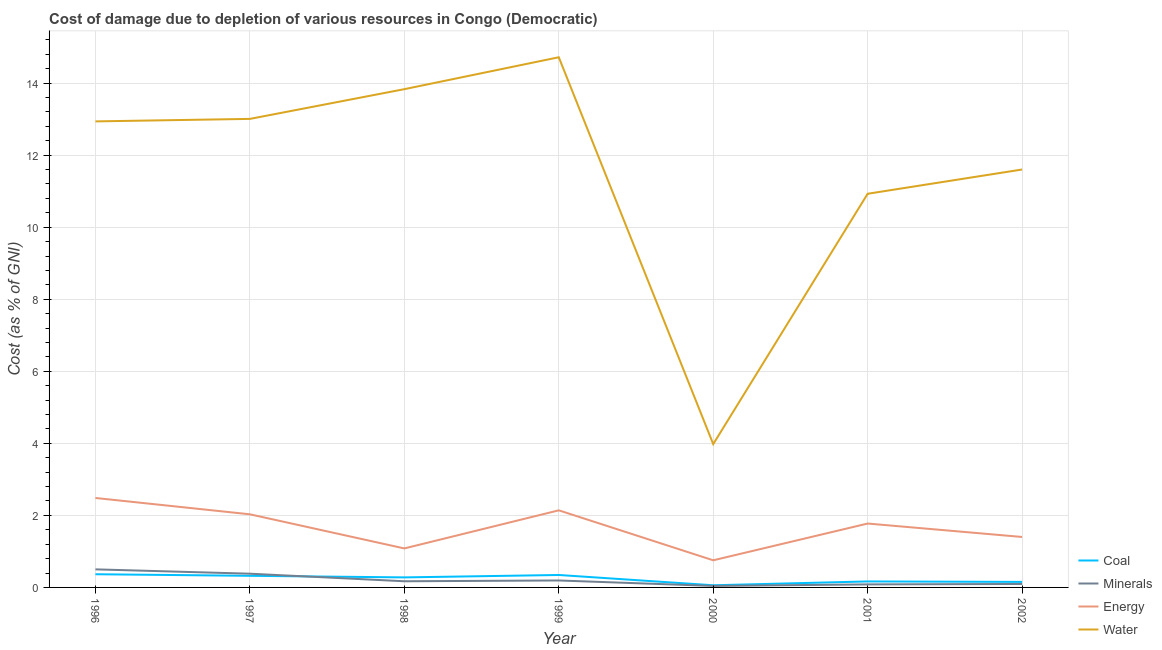What is the cost of damage due to depletion of coal in 1997?
Make the answer very short. 0.32. Across all years, what is the maximum cost of damage due to depletion of water?
Give a very brief answer. 14.72. Across all years, what is the minimum cost of damage due to depletion of water?
Provide a short and direct response. 3.98. What is the total cost of damage due to depletion of water in the graph?
Your answer should be compact. 81. What is the difference between the cost of damage due to depletion of energy in 1997 and that in 2002?
Provide a short and direct response. 0.63. What is the difference between the cost of damage due to depletion of coal in 2001 and the cost of damage due to depletion of water in 1998?
Offer a very short reply. -13.67. What is the average cost of damage due to depletion of coal per year?
Provide a succinct answer. 0.24. In the year 2002, what is the difference between the cost of damage due to depletion of energy and cost of damage due to depletion of water?
Give a very brief answer. -10.2. What is the ratio of the cost of damage due to depletion of coal in 1996 to that in 2002?
Provide a short and direct response. 2.39. Is the difference between the cost of damage due to depletion of minerals in 1998 and 2001 greater than the difference between the cost of damage due to depletion of energy in 1998 and 2001?
Your response must be concise. Yes. What is the difference between the highest and the second highest cost of damage due to depletion of minerals?
Keep it short and to the point. 0.12. What is the difference between the highest and the lowest cost of damage due to depletion of coal?
Ensure brevity in your answer.  0.31. Is it the case that in every year, the sum of the cost of damage due to depletion of coal and cost of damage due to depletion of minerals is greater than the cost of damage due to depletion of energy?
Keep it short and to the point. No. Does the cost of damage due to depletion of coal monotonically increase over the years?
Keep it short and to the point. No. Is the cost of damage due to depletion of coal strictly greater than the cost of damage due to depletion of minerals over the years?
Offer a very short reply. No. How many years are there in the graph?
Your answer should be compact. 7. What is the difference between two consecutive major ticks on the Y-axis?
Offer a very short reply. 2. Does the graph contain grids?
Keep it short and to the point. Yes. How are the legend labels stacked?
Your response must be concise. Vertical. What is the title of the graph?
Make the answer very short. Cost of damage due to depletion of various resources in Congo (Democratic) . Does "Secondary schools" appear as one of the legend labels in the graph?
Your answer should be very brief. No. What is the label or title of the X-axis?
Offer a very short reply. Year. What is the label or title of the Y-axis?
Keep it short and to the point. Cost (as % of GNI). What is the Cost (as % of GNI) in Coal in 1996?
Keep it short and to the point. 0.37. What is the Cost (as % of GNI) in Minerals in 1996?
Make the answer very short. 0.5. What is the Cost (as % of GNI) of Energy in 1996?
Offer a very short reply. 2.48. What is the Cost (as % of GNI) in Water in 1996?
Your answer should be very brief. 12.94. What is the Cost (as % of GNI) of Coal in 1997?
Make the answer very short. 0.32. What is the Cost (as % of GNI) of Minerals in 1997?
Offer a very short reply. 0.38. What is the Cost (as % of GNI) of Energy in 1997?
Your response must be concise. 2.03. What is the Cost (as % of GNI) of Water in 1997?
Your response must be concise. 13.01. What is the Cost (as % of GNI) in Coal in 1998?
Provide a succinct answer. 0.28. What is the Cost (as % of GNI) in Minerals in 1998?
Provide a succinct answer. 0.17. What is the Cost (as % of GNI) in Energy in 1998?
Provide a succinct answer. 1.08. What is the Cost (as % of GNI) in Water in 1998?
Provide a succinct answer. 13.83. What is the Cost (as % of GNI) of Coal in 1999?
Your response must be concise. 0.35. What is the Cost (as % of GNI) in Minerals in 1999?
Provide a succinct answer. 0.19. What is the Cost (as % of GNI) in Energy in 1999?
Ensure brevity in your answer.  2.14. What is the Cost (as % of GNI) of Water in 1999?
Your answer should be very brief. 14.72. What is the Cost (as % of GNI) in Coal in 2000?
Your response must be concise. 0.06. What is the Cost (as % of GNI) in Minerals in 2000?
Ensure brevity in your answer.  0.04. What is the Cost (as % of GNI) of Energy in 2000?
Your response must be concise. 0.75. What is the Cost (as % of GNI) of Water in 2000?
Your response must be concise. 3.98. What is the Cost (as % of GNI) in Coal in 2001?
Ensure brevity in your answer.  0.17. What is the Cost (as % of GNI) in Minerals in 2001?
Offer a terse response. 0.08. What is the Cost (as % of GNI) in Energy in 2001?
Make the answer very short. 1.77. What is the Cost (as % of GNI) in Water in 2001?
Ensure brevity in your answer.  10.93. What is the Cost (as % of GNI) of Coal in 2002?
Give a very brief answer. 0.15. What is the Cost (as % of GNI) of Minerals in 2002?
Your answer should be very brief. 0.1. What is the Cost (as % of GNI) in Energy in 2002?
Keep it short and to the point. 1.4. What is the Cost (as % of GNI) of Water in 2002?
Make the answer very short. 11.6. Across all years, what is the maximum Cost (as % of GNI) of Coal?
Your answer should be compact. 0.37. Across all years, what is the maximum Cost (as % of GNI) of Minerals?
Your answer should be very brief. 0.5. Across all years, what is the maximum Cost (as % of GNI) of Energy?
Offer a very short reply. 2.48. Across all years, what is the maximum Cost (as % of GNI) in Water?
Keep it short and to the point. 14.72. Across all years, what is the minimum Cost (as % of GNI) in Coal?
Your answer should be very brief. 0.06. Across all years, what is the minimum Cost (as % of GNI) in Minerals?
Give a very brief answer. 0.04. Across all years, what is the minimum Cost (as % of GNI) in Energy?
Make the answer very short. 0.75. Across all years, what is the minimum Cost (as % of GNI) of Water?
Provide a succinct answer. 3.98. What is the total Cost (as % of GNI) in Coal in the graph?
Give a very brief answer. 1.69. What is the total Cost (as % of GNI) of Minerals in the graph?
Your answer should be compact. 1.47. What is the total Cost (as % of GNI) of Energy in the graph?
Provide a succinct answer. 11.66. What is the total Cost (as % of GNI) in Water in the graph?
Your answer should be compact. 81. What is the difference between the Cost (as % of GNI) of Coal in 1996 and that in 1997?
Your response must be concise. 0.04. What is the difference between the Cost (as % of GNI) in Minerals in 1996 and that in 1997?
Make the answer very short. 0.12. What is the difference between the Cost (as % of GNI) of Energy in 1996 and that in 1997?
Make the answer very short. 0.45. What is the difference between the Cost (as % of GNI) in Water in 1996 and that in 1997?
Make the answer very short. -0.07. What is the difference between the Cost (as % of GNI) of Coal in 1996 and that in 1998?
Provide a short and direct response. 0.09. What is the difference between the Cost (as % of GNI) in Minerals in 1996 and that in 1998?
Offer a terse response. 0.33. What is the difference between the Cost (as % of GNI) in Energy in 1996 and that in 1998?
Ensure brevity in your answer.  1.4. What is the difference between the Cost (as % of GNI) in Water in 1996 and that in 1998?
Offer a terse response. -0.89. What is the difference between the Cost (as % of GNI) in Coal in 1996 and that in 1999?
Keep it short and to the point. 0.02. What is the difference between the Cost (as % of GNI) of Minerals in 1996 and that in 1999?
Your response must be concise. 0.31. What is the difference between the Cost (as % of GNI) of Energy in 1996 and that in 1999?
Ensure brevity in your answer.  0.34. What is the difference between the Cost (as % of GNI) of Water in 1996 and that in 1999?
Give a very brief answer. -1.78. What is the difference between the Cost (as % of GNI) of Coal in 1996 and that in 2000?
Offer a very short reply. 0.31. What is the difference between the Cost (as % of GNI) in Minerals in 1996 and that in 2000?
Offer a very short reply. 0.46. What is the difference between the Cost (as % of GNI) in Energy in 1996 and that in 2000?
Provide a short and direct response. 1.73. What is the difference between the Cost (as % of GNI) of Water in 1996 and that in 2000?
Your response must be concise. 8.96. What is the difference between the Cost (as % of GNI) in Coal in 1996 and that in 2001?
Your answer should be compact. 0.2. What is the difference between the Cost (as % of GNI) in Minerals in 1996 and that in 2001?
Ensure brevity in your answer.  0.42. What is the difference between the Cost (as % of GNI) of Energy in 1996 and that in 2001?
Ensure brevity in your answer.  0.71. What is the difference between the Cost (as % of GNI) of Water in 1996 and that in 2001?
Give a very brief answer. 2.01. What is the difference between the Cost (as % of GNI) of Coal in 1996 and that in 2002?
Offer a very short reply. 0.21. What is the difference between the Cost (as % of GNI) in Minerals in 1996 and that in 2002?
Ensure brevity in your answer.  0.41. What is the difference between the Cost (as % of GNI) in Energy in 1996 and that in 2002?
Your answer should be compact. 1.08. What is the difference between the Cost (as % of GNI) of Water in 1996 and that in 2002?
Your response must be concise. 1.34. What is the difference between the Cost (as % of GNI) of Coal in 1997 and that in 1998?
Your response must be concise. 0.04. What is the difference between the Cost (as % of GNI) in Minerals in 1997 and that in 1998?
Give a very brief answer. 0.21. What is the difference between the Cost (as % of GNI) in Energy in 1997 and that in 1998?
Make the answer very short. 0.95. What is the difference between the Cost (as % of GNI) in Water in 1997 and that in 1998?
Offer a terse response. -0.83. What is the difference between the Cost (as % of GNI) in Coal in 1997 and that in 1999?
Offer a terse response. -0.02. What is the difference between the Cost (as % of GNI) in Minerals in 1997 and that in 1999?
Provide a short and direct response. 0.19. What is the difference between the Cost (as % of GNI) in Energy in 1997 and that in 1999?
Your response must be concise. -0.11. What is the difference between the Cost (as % of GNI) of Water in 1997 and that in 1999?
Your response must be concise. -1.71. What is the difference between the Cost (as % of GNI) of Coal in 1997 and that in 2000?
Offer a terse response. 0.26. What is the difference between the Cost (as % of GNI) in Minerals in 1997 and that in 2000?
Provide a short and direct response. 0.34. What is the difference between the Cost (as % of GNI) in Energy in 1997 and that in 2000?
Keep it short and to the point. 1.28. What is the difference between the Cost (as % of GNI) in Water in 1997 and that in 2000?
Provide a short and direct response. 9.03. What is the difference between the Cost (as % of GNI) in Coal in 1997 and that in 2001?
Your answer should be very brief. 0.16. What is the difference between the Cost (as % of GNI) in Minerals in 1997 and that in 2001?
Offer a terse response. 0.3. What is the difference between the Cost (as % of GNI) of Energy in 1997 and that in 2001?
Give a very brief answer. 0.26. What is the difference between the Cost (as % of GNI) in Water in 1997 and that in 2001?
Ensure brevity in your answer.  2.08. What is the difference between the Cost (as % of GNI) in Coal in 1997 and that in 2002?
Ensure brevity in your answer.  0.17. What is the difference between the Cost (as % of GNI) of Minerals in 1997 and that in 2002?
Ensure brevity in your answer.  0.28. What is the difference between the Cost (as % of GNI) in Energy in 1997 and that in 2002?
Your response must be concise. 0.63. What is the difference between the Cost (as % of GNI) of Water in 1997 and that in 2002?
Your response must be concise. 1.41. What is the difference between the Cost (as % of GNI) in Coal in 1998 and that in 1999?
Offer a terse response. -0.07. What is the difference between the Cost (as % of GNI) of Minerals in 1998 and that in 1999?
Your answer should be very brief. -0.02. What is the difference between the Cost (as % of GNI) in Energy in 1998 and that in 1999?
Provide a short and direct response. -1.06. What is the difference between the Cost (as % of GNI) in Water in 1998 and that in 1999?
Offer a very short reply. -0.89. What is the difference between the Cost (as % of GNI) of Coal in 1998 and that in 2000?
Provide a succinct answer. 0.22. What is the difference between the Cost (as % of GNI) of Minerals in 1998 and that in 2000?
Provide a succinct answer. 0.13. What is the difference between the Cost (as % of GNI) in Energy in 1998 and that in 2000?
Give a very brief answer. 0.33. What is the difference between the Cost (as % of GNI) of Water in 1998 and that in 2000?
Provide a short and direct response. 9.85. What is the difference between the Cost (as % of GNI) of Coal in 1998 and that in 2001?
Give a very brief answer. 0.11. What is the difference between the Cost (as % of GNI) of Minerals in 1998 and that in 2001?
Provide a short and direct response. 0.09. What is the difference between the Cost (as % of GNI) of Energy in 1998 and that in 2001?
Your answer should be very brief. -0.69. What is the difference between the Cost (as % of GNI) in Water in 1998 and that in 2001?
Offer a terse response. 2.9. What is the difference between the Cost (as % of GNI) of Coal in 1998 and that in 2002?
Your response must be concise. 0.13. What is the difference between the Cost (as % of GNI) of Minerals in 1998 and that in 2002?
Offer a terse response. 0.07. What is the difference between the Cost (as % of GNI) in Energy in 1998 and that in 2002?
Your answer should be very brief. -0.32. What is the difference between the Cost (as % of GNI) in Water in 1998 and that in 2002?
Your answer should be very brief. 2.23. What is the difference between the Cost (as % of GNI) in Coal in 1999 and that in 2000?
Provide a short and direct response. 0.29. What is the difference between the Cost (as % of GNI) in Minerals in 1999 and that in 2000?
Ensure brevity in your answer.  0.15. What is the difference between the Cost (as % of GNI) in Energy in 1999 and that in 2000?
Your response must be concise. 1.39. What is the difference between the Cost (as % of GNI) of Water in 1999 and that in 2000?
Offer a very short reply. 10.74. What is the difference between the Cost (as % of GNI) of Coal in 1999 and that in 2001?
Keep it short and to the point. 0.18. What is the difference between the Cost (as % of GNI) in Minerals in 1999 and that in 2001?
Offer a terse response. 0.11. What is the difference between the Cost (as % of GNI) of Energy in 1999 and that in 2001?
Make the answer very short. 0.37. What is the difference between the Cost (as % of GNI) in Water in 1999 and that in 2001?
Ensure brevity in your answer.  3.79. What is the difference between the Cost (as % of GNI) of Coal in 1999 and that in 2002?
Offer a very short reply. 0.19. What is the difference between the Cost (as % of GNI) in Minerals in 1999 and that in 2002?
Keep it short and to the point. 0.1. What is the difference between the Cost (as % of GNI) in Energy in 1999 and that in 2002?
Offer a very short reply. 0.74. What is the difference between the Cost (as % of GNI) of Water in 1999 and that in 2002?
Your response must be concise. 3.12. What is the difference between the Cost (as % of GNI) of Coal in 2000 and that in 2001?
Your response must be concise. -0.11. What is the difference between the Cost (as % of GNI) in Minerals in 2000 and that in 2001?
Offer a very short reply. -0.04. What is the difference between the Cost (as % of GNI) in Energy in 2000 and that in 2001?
Offer a terse response. -1.02. What is the difference between the Cost (as % of GNI) of Water in 2000 and that in 2001?
Your answer should be compact. -6.95. What is the difference between the Cost (as % of GNI) of Coal in 2000 and that in 2002?
Keep it short and to the point. -0.09. What is the difference between the Cost (as % of GNI) in Minerals in 2000 and that in 2002?
Give a very brief answer. -0.05. What is the difference between the Cost (as % of GNI) of Energy in 2000 and that in 2002?
Provide a short and direct response. -0.65. What is the difference between the Cost (as % of GNI) of Water in 2000 and that in 2002?
Make the answer very short. -7.62. What is the difference between the Cost (as % of GNI) in Coal in 2001 and that in 2002?
Your response must be concise. 0.01. What is the difference between the Cost (as % of GNI) in Minerals in 2001 and that in 2002?
Ensure brevity in your answer.  -0.01. What is the difference between the Cost (as % of GNI) in Energy in 2001 and that in 2002?
Your answer should be compact. 0.37. What is the difference between the Cost (as % of GNI) of Water in 2001 and that in 2002?
Make the answer very short. -0.67. What is the difference between the Cost (as % of GNI) in Coal in 1996 and the Cost (as % of GNI) in Minerals in 1997?
Your response must be concise. -0.01. What is the difference between the Cost (as % of GNI) of Coal in 1996 and the Cost (as % of GNI) of Energy in 1997?
Provide a succinct answer. -1.66. What is the difference between the Cost (as % of GNI) of Coal in 1996 and the Cost (as % of GNI) of Water in 1997?
Ensure brevity in your answer.  -12.64. What is the difference between the Cost (as % of GNI) in Minerals in 1996 and the Cost (as % of GNI) in Energy in 1997?
Keep it short and to the point. -1.53. What is the difference between the Cost (as % of GNI) of Minerals in 1996 and the Cost (as % of GNI) of Water in 1997?
Make the answer very short. -12.51. What is the difference between the Cost (as % of GNI) of Energy in 1996 and the Cost (as % of GNI) of Water in 1997?
Ensure brevity in your answer.  -10.52. What is the difference between the Cost (as % of GNI) in Coal in 1996 and the Cost (as % of GNI) in Minerals in 1998?
Your answer should be compact. 0.2. What is the difference between the Cost (as % of GNI) in Coal in 1996 and the Cost (as % of GNI) in Energy in 1998?
Your answer should be very brief. -0.72. What is the difference between the Cost (as % of GNI) in Coal in 1996 and the Cost (as % of GNI) in Water in 1998?
Give a very brief answer. -13.47. What is the difference between the Cost (as % of GNI) in Minerals in 1996 and the Cost (as % of GNI) in Energy in 1998?
Your response must be concise. -0.58. What is the difference between the Cost (as % of GNI) in Minerals in 1996 and the Cost (as % of GNI) in Water in 1998?
Ensure brevity in your answer.  -13.33. What is the difference between the Cost (as % of GNI) of Energy in 1996 and the Cost (as % of GNI) of Water in 1998?
Your answer should be compact. -11.35. What is the difference between the Cost (as % of GNI) of Coal in 1996 and the Cost (as % of GNI) of Minerals in 1999?
Provide a succinct answer. 0.17. What is the difference between the Cost (as % of GNI) of Coal in 1996 and the Cost (as % of GNI) of Energy in 1999?
Provide a short and direct response. -1.77. What is the difference between the Cost (as % of GNI) of Coal in 1996 and the Cost (as % of GNI) of Water in 1999?
Your response must be concise. -14.35. What is the difference between the Cost (as % of GNI) in Minerals in 1996 and the Cost (as % of GNI) in Energy in 1999?
Your response must be concise. -1.64. What is the difference between the Cost (as % of GNI) in Minerals in 1996 and the Cost (as % of GNI) in Water in 1999?
Make the answer very short. -14.22. What is the difference between the Cost (as % of GNI) of Energy in 1996 and the Cost (as % of GNI) of Water in 1999?
Keep it short and to the point. -12.23. What is the difference between the Cost (as % of GNI) in Coal in 1996 and the Cost (as % of GNI) in Minerals in 2000?
Your response must be concise. 0.32. What is the difference between the Cost (as % of GNI) in Coal in 1996 and the Cost (as % of GNI) in Energy in 2000?
Provide a short and direct response. -0.39. What is the difference between the Cost (as % of GNI) in Coal in 1996 and the Cost (as % of GNI) in Water in 2000?
Ensure brevity in your answer.  -3.61. What is the difference between the Cost (as % of GNI) of Minerals in 1996 and the Cost (as % of GNI) of Energy in 2000?
Ensure brevity in your answer.  -0.25. What is the difference between the Cost (as % of GNI) of Minerals in 1996 and the Cost (as % of GNI) of Water in 2000?
Make the answer very short. -3.48. What is the difference between the Cost (as % of GNI) in Energy in 1996 and the Cost (as % of GNI) in Water in 2000?
Keep it short and to the point. -1.5. What is the difference between the Cost (as % of GNI) in Coal in 1996 and the Cost (as % of GNI) in Minerals in 2001?
Provide a short and direct response. 0.28. What is the difference between the Cost (as % of GNI) in Coal in 1996 and the Cost (as % of GNI) in Energy in 2001?
Your answer should be very brief. -1.41. What is the difference between the Cost (as % of GNI) in Coal in 1996 and the Cost (as % of GNI) in Water in 2001?
Ensure brevity in your answer.  -10.56. What is the difference between the Cost (as % of GNI) of Minerals in 1996 and the Cost (as % of GNI) of Energy in 2001?
Your response must be concise. -1.27. What is the difference between the Cost (as % of GNI) in Minerals in 1996 and the Cost (as % of GNI) in Water in 2001?
Provide a short and direct response. -10.43. What is the difference between the Cost (as % of GNI) of Energy in 1996 and the Cost (as % of GNI) of Water in 2001?
Provide a succinct answer. -8.45. What is the difference between the Cost (as % of GNI) of Coal in 1996 and the Cost (as % of GNI) of Minerals in 2002?
Your answer should be compact. 0.27. What is the difference between the Cost (as % of GNI) in Coal in 1996 and the Cost (as % of GNI) in Energy in 2002?
Offer a terse response. -1.03. What is the difference between the Cost (as % of GNI) in Coal in 1996 and the Cost (as % of GNI) in Water in 2002?
Your answer should be very brief. -11.24. What is the difference between the Cost (as % of GNI) of Minerals in 1996 and the Cost (as % of GNI) of Energy in 2002?
Make the answer very short. -0.9. What is the difference between the Cost (as % of GNI) in Minerals in 1996 and the Cost (as % of GNI) in Water in 2002?
Ensure brevity in your answer.  -11.1. What is the difference between the Cost (as % of GNI) of Energy in 1996 and the Cost (as % of GNI) of Water in 2002?
Offer a very short reply. -9.12. What is the difference between the Cost (as % of GNI) in Coal in 1997 and the Cost (as % of GNI) in Minerals in 1998?
Ensure brevity in your answer.  0.15. What is the difference between the Cost (as % of GNI) in Coal in 1997 and the Cost (as % of GNI) in Energy in 1998?
Your response must be concise. -0.76. What is the difference between the Cost (as % of GNI) in Coal in 1997 and the Cost (as % of GNI) in Water in 1998?
Your answer should be very brief. -13.51. What is the difference between the Cost (as % of GNI) of Minerals in 1997 and the Cost (as % of GNI) of Energy in 1998?
Provide a short and direct response. -0.7. What is the difference between the Cost (as % of GNI) in Minerals in 1997 and the Cost (as % of GNI) in Water in 1998?
Give a very brief answer. -13.45. What is the difference between the Cost (as % of GNI) of Energy in 1997 and the Cost (as % of GNI) of Water in 1998?
Offer a terse response. -11.8. What is the difference between the Cost (as % of GNI) in Coal in 1997 and the Cost (as % of GNI) in Minerals in 1999?
Ensure brevity in your answer.  0.13. What is the difference between the Cost (as % of GNI) in Coal in 1997 and the Cost (as % of GNI) in Energy in 1999?
Your answer should be very brief. -1.82. What is the difference between the Cost (as % of GNI) in Coal in 1997 and the Cost (as % of GNI) in Water in 1999?
Your response must be concise. -14.4. What is the difference between the Cost (as % of GNI) of Minerals in 1997 and the Cost (as % of GNI) of Energy in 1999?
Give a very brief answer. -1.76. What is the difference between the Cost (as % of GNI) in Minerals in 1997 and the Cost (as % of GNI) in Water in 1999?
Your answer should be compact. -14.34. What is the difference between the Cost (as % of GNI) in Energy in 1997 and the Cost (as % of GNI) in Water in 1999?
Give a very brief answer. -12.69. What is the difference between the Cost (as % of GNI) of Coal in 1997 and the Cost (as % of GNI) of Minerals in 2000?
Offer a very short reply. 0.28. What is the difference between the Cost (as % of GNI) in Coal in 1997 and the Cost (as % of GNI) in Energy in 2000?
Your response must be concise. -0.43. What is the difference between the Cost (as % of GNI) of Coal in 1997 and the Cost (as % of GNI) of Water in 2000?
Keep it short and to the point. -3.66. What is the difference between the Cost (as % of GNI) of Minerals in 1997 and the Cost (as % of GNI) of Energy in 2000?
Make the answer very short. -0.37. What is the difference between the Cost (as % of GNI) in Minerals in 1997 and the Cost (as % of GNI) in Water in 2000?
Offer a terse response. -3.6. What is the difference between the Cost (as % of GNI) of Energy in 1997 and the Cost (as % of GNI) of Water in 2000?
Offer a terse response. -1.95. What is the difference between the Cost (as % of GNI) in Coal in 1997 and the Cost (as % of GNI) in Minerals in 2001?
Your response must be concise. 0.24. What is the difference between the Cost (as % of GNI) of Coal in 1997 and the Cost (as % of GNI) of Energy in 2001?
Keep it short and to the point. -1.45. What is the difference between the Cost (as % of GNI) of Coal in 1997 and the Cost (as % of GNI) of Water in 2001?
Keep it short and to the point. -10.61. What is the difference between the Cost (as % of GNI) in Minerals in 1997 and the Cost (as % of GNI) in Energy in 2001?
Make the answer very short. -1.39. What is the difference between the Cost (as % of GNI) in Minerals in 1997 and the Cost (as % of GNI) in Water in 2001?
Your answer should be compact. -10.55. What is the difference between the Cost (as % of GNI) in Energy in 1997 and the Cost (as % of GNI) in Water in 2001?
Your answer should be very brief. -8.9. What is the difference between the Cost (as % of GNI) of Coal in 1997 and the Cost (as % of GNI) of Minerals in 2002?
Offer a very short reply. 0.23. What is the difference between the Cost (as % of GNI) of Coal in 1997 and the Cost (as % of GNI) of Energy in 2002?
Your answer should be compact. -1.08. What is the difference between the Cost (as % of GNI) in Coal in 1997 and the Cost (as % of GNI) in Water in 2002?
Make the answer very short. -11.28. What is the difference between the Cost (as % of GNI) in Minerals in 1997 and the Cost (as % of GNI) in Energy in 2002?
Offer a terse response. -1.02. What is the difference between the Cost (as % of GNI) in Minerals in 1997 and the Cost (as % of GNI) in Water in 2002?
Make the answer very short. -11.22. What is the difference between the Cost (as % of GNI) of Energy in 1997 and the Cost (as % of GNI) of Water in 2002?
Provide a short and direct response. -9.57. What is the difference between the Cost (as % of GNI) in Coal in 1998 and the Cost (as % of GNI) in Minerals in 1999?
Give a very brief answer. 0.09. What is the difference between the Cost (as % of GNI) of Coal in 1998 and the Cost (as % of GNI) of Energy in 1999?
Offer a very short reply. -1.86. What is the difference between the Cost (as % of GNI) of Coal in 1998 and the Cost (as % of GNI) of Water in 1999?
Ensure brevity in your answer.  -14.44. What is the difference between the Cost (as % of GNI) in Minerals in 1998 and the Cost (as % of GNI) in Energy in 1999?
Make the answer very short. -1.97. What is the difference between the Cost (as % of GNI) of Minerals in 1998 and the Cost (as % of GNI) of Water in 1999?
Your response must be concise. -14.55. What is the difference between the Cost (as % of GNI) in Energy in 1998 and the Cost (as % of GNI) in Water in 1999?
Offer a very short reply. -13.64. What is the difference between the Cost (as % of GNI) of Coal in 1998 and the Cost (as % of GNI) of Minerals in 2000?
Provide a succinct answer. 0.24. What is the difference between the Cost (as % of GNI) of Coal in 1998 and the Cost (as % of GNI) of Energy in 2000?
Provide a succinct answer. -0.47. What is the difference between the Cost (as % of GNI) of Coal in 1998 and the Cost (as % of GNI) of Water in 2000?
Your response must be concise. -3.7. What is the difference between the Cost (as % of GNI) of Minerals in 1998 and the Cost (as % of GNI) of Energy in 2000?
Make the answer very short. -0.58. What is the difference between the Cost (as % of GNI) of Minerals in 1998 and the Cost (as % of GNI) of Water in 2000?
Give a very brief answer. -3.81. What is the difference between the Cost (as % of GNI) in Energy in 1998 and the Cost (as % of GNI) in Water in 2000?
Ensure brevity in your answer.  -2.9. What is the difference between the Cost (as % of GNI) in Coal in 1998 and the Cost (as % of GNI) in Minerals in 2001?
Ensure brevity in your answer.  0.2. What is the difference between the Cost (as % of GNI) of Coal in 1998 and the Cost (as % of GNI) of Energy in 2001?
Offer a terse response. -1.49. What is the difference between the Cost (as % of GNI) in Coal in 1998 and the Cost (as % of GNI) in Water in 2001?
Make the answer very short. -10.65. What is the difference between the Cost (as % of GNI) in Minerals in 1998 and the Cost (as % of GNI) in Energy in 2001?
Give a very brief answer. -1.6. What is the difference between the Cost (as % of GNI) in Minerals in 1998 and the Cost (as % of GNI) in Water in 2001?
Make the answer very short. -10.76. What is the difference between the Cost (as % of GNI) in Energy in 1998 and the Cost (as % of GNI) in Water in 2001?
Your response must be concise. -9.85. What is the difference between the Cost (as % of GNI) in Coal in 1998 and the Cost (as % of GNI) in Minerals in 2002?
Your response must be concise. 0.18. What is the difference between the Cost (as % of GNI) in Coal in 1998 and the Cost (as % of GNI) in Energy in 2002?
Make the answer very short. -1.12. What is the difference between the Cost (as % of GNI) in Coal in 1998 and the Cost (as % of GNI) in Water in 2002?
Offer a terse response. -11.32. What is the difference between the Cost (as % of GNI) in Minerals in 1998 and the Cost (as % of GNI) in Energy in 2002?
Ensure brevity in your answer.  -1.23. What is the difference between the Cost (as % of GNI) in Minerals in 1998 and the Cost (as % of GNI) in Water in 2002?
Provide a short and direct response. -11.43. What is the difference between the Cost (as % of GNI) of Energy in 1998 and the Cost (as % of GNI) of Water in 2002?
Ensure brevity in your answer.  -10.52. What is the difference between the Cost (as % of GNI) of Coal in 1999 and the Cost (as % of GNI) of Minerals in 2000?
Give a very brief answer. 0.3. What is the difference between the Cost (as % of GNI) in Coal in 1999 and the Cost (as % of GNI) in Energy in 2000?
Ensure brevity in your answer.  -0.41. What is the difference between the Cost (as % of GNI) of Coal in 1999 and the Cost (as % of GNI) of Water in 2000?
Ensure brevity in your answer.  -3.63. What is the difference between the Cost (as % of GNI) of Minerals in 1999 and the Cost (as % of GNI) of Energy in 2000?
Provide a short and direct response. -0.56. What is the difference between the Cost (as % of GNI) of Minerals in 1999 and the Cost (as % of GNI) of Water in 2000?
Give a very brief answer. -3.79. What is the difference between the Cost (as % of GNI) of Energy in 1999 and the Cost (as % of GNI) of Water in 2000?
Offer a very short reply. -1.84. What is the difference between the Cost (as % of GNI) of Coal in 1999 and the Cost (as % of GNI) of Minerals in 2001?
Offer a very short reply. 0.26. What is the difference between the Cost (as % of GNI) of Coal in 1999 and the Cost (as % of GNI) of Energy in 2001?
Give a very brief answer. -1.43. What is the difference between the Cost (as % of GNI) in Coal in 1999 and the Cost (as % of GNI) in Water in 2001?
Offer a very short reply. -10.58. What is the difference between the Cost (as % of GNI) of Minerals in 1999 and the Cost (as % of GNI) of Energy in 2001?
Keep it short and to the point. -1.58. What is the difference between the Cost (as % of GNI) in Minerals in 1999 and the Cost (as % of GNI) in Water in 2001?
Provide a succinct answer. -10.74. What is the difference between the Cost (as % of GNI) of Energy in 1999 and the Cost (as % of GNI) of Water in 2001?
Offer a very short reply. -8.79. What is the difference between the Cost (as % of GNI) of Coal in 1999 and the Cost (as % of GNI) of Minerals in 2002?
Make the answer very short. 0.25. What is the difference between the Cost (as % of GNI) of Coal in 1999 and the Cost (as % of GNI) of Energy in 2002?
Give a very brief answer. -1.06. What is the difference between the Cost (as % of GNI) of Coal in 1999 and the Cost (as % of GNI) of Water in 2002?
Provide a succinct answer. -11.26. What is the difference between the Cost (as % of GNI) in Minerals in 1999 and the Cost (as % of GNI) in Energy in 2002?
Ensure brevity in your answer.  -1.21. What is the difference between the Cost (as % of GNI) of Minerals in 1999 and the Cost (as % of GNI) of Water in 2002?
Offer a very short reply. -11.41. What is the difference between the Cost (as % of GNI) of Energy in 1999 and the Cost (as % of GNI) of Water in 2002?
Keep it short and to the point. -9.46. What is the difference between the Cost (as % of GNI) of Coal in 2000 and the Cost (as % of GNI) of Minerals in 2001?
Give a very brief answer. -0.02. What is the difference between the Cost (as % of GNI) of Coal in 2000 and the Cost (as % of GNI) of Energy in 2001?
Make the answer very short. -1.71. What is the difference between the Cost (as % of GNI) of Coal in 2000 and the Cost (as % of GNI) of Water in 2001?
Make the answer very short. -10.87. What is the difference between the Cost (as % of GNI) of Minerals in 2000 and the Cost (as % of GNI) of Energy in 2001?
Provide a short and direct response. -1.73. What is the difference between the Cost (as % of GNI) of Minerals in 2000 and the Cost (as % of GNI) of Water in 2001?
Give a very brief answer. -10.89. What is the difference between the Cost (as % of GNI) of Energy in 2000 and the Cost (as % of GNI) of Water in 2001?
Give a very brief answer. -10.18. What is the difference between the Cost (as % of GNI) in Coal in 2000 and the Cost (as % of GNI) in Minerals in 2002?
Offer a very short reply. -0.04. What is the difference between the Cost (as % of GNI) of Coal in 2000 and the Cost (as % of GNI) of Energy in 2002?
Give a very brief answer. -1.34. What is the difference between the Cost (as % of GNI) of Coal in 2000 and the Cost (as % of GNI) of Water in 2002?
Provide a short and direct response. -11.54. What is the difference between the Cost (as % of GNI) in Minerals in 2000 and the Cost (as % of GNI) in Energy in 2002?
Your answer should be compact. -1.36. What is the difference between the Cost (as % of GNI) of Minerals in 2000 and the Cost (as % of GNI) of Water in 2002?
Your response must be concise. -11.56. What is the difference between the Cost (as % of GNI) of Energy in 2000 and the Cost (as % of GNI) of Water in 2002?
Provide a succinct answer. -10.85. What is the difference between the Cost (as % of GNI) of Coal in 2001 and the Cost (as % of GNI) of Minerals in 2002?
Provide a succinct answer. 0.07. What is the difference between the Cost (as % of GNI) of Coal in 2001 and the Cost (as % of GNI) of Energy in 2002?
Provide a short and direct response. -1.23. What is the difference between the Cost (as % of GNI) in Coal in 2001 and the Cost (as % of GNI) in Water in 2002?
Keep it short and to the point. -11.44. What is the difference between the Cost (as % of GNI) in Minerals in 2001 and the Cost (as % of GNI) in Energy in 2002?
Your answer should be very brief. -1.32. What is the difference between the Cost (as % of GNI) in Minerals in 2001 and the Cost (as % of GNI) in Water in 2002?
Ensure brevity in your answer.  -11.52. What is the difference between the Cost (as % of GNI) in Energy in 2001 and the Cost (as % of GNI) in Water in 2002?
Offer a very short reply. -9.83. What is the average Cost (as % of GNI) in Coal per year?
Your answer should be very brief. 0.24. What is the average Cost (as % of GNI) in Minerals per year?
Your answer should be compact. 0.21. What is the average Cost (as % of GNI) of Energy per year?
Provide a succinct answer. 1.67. What is the average Cost (as % of GNI) in Water per year?
Provide a succinct answer. 11.57. In the year 1996, what is the difference between the Cost (as % of GNI) of Coal and Cost (as % of GNI) of Minerals?
Make the answer very short. -0.14. In the year 1996, what is the difference between the Cost (as % of GNI) of Coal and Cost (as % of GNI) of Energy?
Provide a succinct answer. -2.12. In the year 1996, what is the difference between the Cost (as % of GNI) in Coal and Cost (as % of GNI) in Water?
Your answer should be compact. -12.57. In the year 1996, what is the difference between the Cost (as % of GNI) in Minerals and Cost (as % of GNI) in Energy?
Your answer should be compact. -1.98. In the year 1996, what is the difference between the Cost (as % of GNI) of Minerals and Cost (as % of GNI) of Water?
Make the answer very short. -12.44. In the year 1996, what is the difference between the Cost (as % of GNI) of Energy and Cost (as % of GNI) of Water?
Give a very brief answer. -10.45. In the year 1997, what is the difference between the Cost (as % of GNI) in Coal and Cost (as % of GNI) in Minerals?
Offer a very short reply. -0.06. In the year 1997, what is the difference between the Cost (as % of GNI) of Coal and Cost (as % of GNI) of Energy?
Offer a very short reply. -1.71. In the year 1997, what is the difference between the Cost (as % of GNI) of Coal and Cost (as % of GNI) of Water?
Your answer should be compact. -12.68. In the year 1997, what is the difference between the Cost (as % of GNI) in Minerals and Cost (as % of GNI) in Energy?
Offer a terse response. -1.65. In the year 1997, what is the difference between the Cost (as % of GNI) of Minerals and Cost (as % of GNI) of Water?
Give a very brief answer. -12.63. In the year 1997, what is the difference between the Cost (as % of GNI) of Energy and Cost (as % of GNI) of Water?
Your answer should be very brief. -10.98. In the year 1998, what is the difference between the Cost (as % of GNI) of Coal and Cost (as % of GNI) of Minerals?
Your response must be concise. 0.11. In the year 1998, what is the difference between the Cost (as % of GNI) of Coal and Cost (as % of GNI) of Energy?
Your answer should be very brief. -0.8. In the year 1998, what is the difference between the Cost (as % of GNI) in Coal and Cost (as % of GNI) in Water?
Your answer should be very brief. -13.55. In the year 1998, what is the difference between the Cost (as % of GNI) in Minerals and Cost (as % of GNI) in Energy?
Your answer should be very brief. -0.91. In the year 1998, what is the difference between the Cost (as % of GNI) of Minerals and Cost (as % of GNI) of Water?
Your answer should be compact. -13.66. In the year 1998, what is the difference between the Cost (as % of GNI) in Energy and Cost (as % of GNI) in Water?
Provide a short and direct response. -12.75. In the year 1999, what is the difference between the Cost (as % of GNI) in Coal and Cost (as % of GNI) in Minerals?
Your response must be concise. 0.15. In the year 1999, what is the difference between the Cost (as % of GNI) of Coal and Cost (as % of GNI) of Energy?
Offer a terse response. -1.79. In the year 1999, what is the difference between the Cost (as % of GNI) in Coal and Cost (as % of GNI) in Water?
Give a very brief answer. -14.37. In the year 1999, what is the difference between the Cost (as % of GNI) in Minerals and Cost (as % of GNI) in Energy?
Your answer should be compact. -1.95. In the year 1999, what is the difference between the Cost (as % of GNI) of Minerals and Cost (as % of GNI) of Water?
Your answer should be compact. -14.53. In the year 1999, what is the difference between the Cost (as % of GNI) in Energy and Cost (as % of GNI) in Water?
Your answer should be compact. -12.58. In the year 2000, what is the difference between the Cost (as % of GNI) in Coal and Cost (as % of GNI) in Minerals?
Offer a terse response. 0.02. In the year 2000, what is the difference between the Cost (as % of GNI) in Coal and Cost (as % of GNI) in Energy?
Make the answer very short. -0.69. In the year 2000, what is the difference between the Cost (as % of GNI) in Coal and Cost (as % of GNI) in Water?
Your answer should be compact. -3.92. In the year 2000, what is the difference between the Cost (as % of GNI) in Minerals and Cost (as % of GNI) in Energy?
Your answer should be very brief. -0.71. In the year 2000, what is the difference between the Cost (as % of GNI) in Minerals and Cost (as % of GNI) in Water?
Make the answer very short. -3.94. In the year 2000, what is the difference between the Cost (as % of GNI) of Energy and Cost (as % of GNI) of Water?
Provide a succinct answer. -3.23. In the year 2001, what is the difference between the Cost (as % of GNI) in Coal and Cost (as % of GNI) in Minerals?
Your answer should be very brief. 0.08. In the year 2001, what is the difference between the Cost (as % of GNI) of Coal and Cost (as % of GNI) of Energy?
Give a very brief answer. -1.61. In the year 2001, what is the difference between the Cost (as % of GNI) of Coal and Cost (as % of GNI) of Water?
Keep it short and to the point. -10.76. In the year 2001, what is the difference between the Cost (as % of GNI) of Minerals and Cost (as % of GNI) of Energy?
Your answer should be compact. -1.69. In the year 2001, what is the difference between the Cost (as % of GNI) of Minerals and Cost (as % of GNI) of Water?
Keep it short and to the point. -10.85. In the year 2001, what is the difference between the Cost (as % of GNI) in Energy and Cost (as % of GNI) in Water?
Your answer should be very brief. -9.16. In the year 2002, what is the difference between the Cost (as % of GNI) in Coal and Cost (as % of GNI) in Minerals?
Ensure brevity in your answer.  0.06. In the year 2002, what is the difference between the Cost (as % of GNI) in Coal and Cost (as % of GNI) in Energy?
Offer a terse response. -1.25. In the year 2002, what is the difference between the Cost (as % of GNI) of Coal and Cost (as % of GNI) of Water?
Make the answer very short. -11.45. In the year 2002, what is the difference between the Cost (as % of GNI) in Minerals and Cost (as % of GNI) in Energy?
Make the answer very short. -1.3. In the year 2002, what is the difference between the Cost (as % of GNI) in Minerals and Cost (as % of GNI) in Water?
Provide a succinct answer. -11.51. In the year 2002, what is the difference between the Cost (as % of GNI) of Energy and Cost (as % of GNI) of Water?
Provide a short and direct response. -10.2. What is the ratio of the Cost (as % of GNI) in Coal in 1996 to that in 1997?
Your answer should be very brief. 1.14. What is the ratio of the Cost (as % of GNI) in Minerals in 1996 to that in 1997?
Give a very brief answer. 1.32. What is the ratio of the Cost (as % of GNI) of Energy in 1996 to that in 1997?
Keep it short and to the point. 1.22. What is the ratio of the Cost (as % of GNI) in Coal in 1996 to that in 1998?
Offer a very short reply. 1.31. What is the ratio of the Cost (as % of GNI) of Minerals in 1996 to that in 1998?
Give a very brief answer. 2.93. What is the ratio of the Cost (as % of GNI) of Energy in 1996 to that in 1998?
Your answer should be very brief. 2.29. What is the ratio of the Cost (as % of GNI) in Water in 1996 to that in 1998?
Your answer should be very brief. 0.94. What is the ratio of the Cost (as % of GNI) in Coal in 1996 to that in 1999?
Ensure brevity in your answer.  1.06. What is the ratio of the Cost (as % of GNI) in Minerals in 1996 to that in 1999?
Offer a terse response. 2.6. What is the ratio of the Cost (as % of GNI) of Energy in 1996 to that in 1999?
Your answer should be compact. 1.16. What is the ratio of the Cost (as % of GNI) of Water in 1996 to that in 1999?
Your answer should be very brief. 0.88. What is the ratio of the Cost (as % of GNI) of Coal in 1996 to that in 2000?
Give a very brief answer. 6.11. What is the ratio of the Cost (as % of GNI) in Minerals in 1996 to that in 2000?
Your answer should be compact. 12.04. What is the ratio of the Cost (as % of GNI) in Energy in 1996 to that in 2000?
Ensure brevity in your answer.  3.3. What is the ratio of the Cost (as % of GNI) in Water in 1996 to that in 2000?
Give a very brief answer. 3.25. What is the ratio of the Cost (as % of GNI) of Coal in 1996 to that in 2001?
Ensure brevity in your answer.  2.21. What is the ratio of the Cost (as % of GNI) in Minerals in 1996 to that in 2001?
Make the answer very short. 5.99. What is the ratio of the Cost (as % of GNI) in Energy in 1996 to that in 2001?
Provide a succinct answer. 1.4. What is the ratio of the Cost (as % of GNI) of Water in 1996 to that in 2001?
Ensure brevity in your answer.  1.18. What is the ratio of the Cost (as % of GNI) of Coal in 1996 to that in 2002?
Provide a short and direct response. 2.39. What is the ratio of the Cost (as % of GNI) in Minerals in 1996 to that in 2002?
Your answer should be compact. 5.22. What is the ratio of the Cost (as % of GNI) in Energy in 1996 to that in 2002?
Your answer should be very brief. 1.77. What is the ratio of the Cost (as % of GNI) of Water in 1996 to that in 2002?
Offer a very short reply. 1.12. What is the ratio of the Cost (as % of GNI) in Coal in 1997 to that in 1998?
Your answer should be compact. 1.16. What is the ratio of the Cost (as % of GNI) of Minerals in 1997 to that in 1998?
Ensure brevity in your answer.  2.23. What is the ratio of the Cost (as % of GNI) of Energy in 1997 to that in 1998?
Ensure brevity in your answer.  1.88. What is the ratio of the Cost (as % of GNI) in Water in 1997 to that in 1998?
Offer a very short reply. 0.94. What is the ratio of the Cost (as % of GNI) of Coal in 1997 to that in 1999?
Provide a short and direct response. 0.93. What is the ratio of the Cost (as % of GNI) in Minerals in 1997 to that in 1999?
Ensure brevity in your answer.  1.98. What is the ratio of the Cost (as % of GNI) of Energy in 1997 to that in 1999?
Your answer should be very brief. 0.95. What is the ratio of the Cost (as % of GNI) of Water in 1997 to that in 1999?
Give a very brief answer. 0.88. What is the ratio of the Cost (as % of GNI) of Coal in 1997 to that in 2000?
Keep it short and to the point. 5.38. What is the ratio of the Cost (as % of GNI) in Minerals in 1997 to that in 2000?
Make the answer very short. 9.15. What is the ratio of the Cost (as % of GNI) of Energy in 1997 to that in 2000?
Your answer should be very brief. 2.7. What is the ratio of the Cost (as % of GNI) of Water in 1997 to that in 2000?
Ensure brevity in your answer.  3.27. What is the ratio of the Cost (as % of GNI) of Coal in 1997 to that in 2001?
Your answer should be compact. 1.94. What is the ratio of the Cost (as % of GNI) of Minerals in 1997 to that in 2001?
Your answer should be compact. 4.55. What is the ratio of the Cost (as % of GNI) in Energy in 1997 to that in 2001?
Give a very brief answer. 1.14. What is the ratio of the Cost (as % of GNI) of Water in 1997 to that in 2001?
Ensure brevity in your answer.  1.19. What is the ratio of the Cost (as % of GNI) of Coal in 1997 to that in 2002?
Offer a terse response. 2.11. What is the ratio of the Cost (as % of GNI) in Minerals in 1997 to that in 2002?
Provide a short and direct response. 3.96. What is the ratio of the Cost (as % of GNI) in Energy in 1997 to that in 2002?
Your answer should be very brief. 1.45. What is the ratio of the Cost (as % of GNI) in Water in 1997 to that in 2002?
Provide a short and direct response. 1.12. What is the ratio of the Cost (as % of GNI) in Coal in 1998 to that in 1999?
Keep it short and to the point. 0.81. What is the ratio of the Cost (as % of GNI) in Minerals in 1998 to that in 1999?
Give a very brief answer. 0.89. What is the ratio of the Cost (as % of GNI) in Energy in 1998 to that in 1999?
Your answer should be compact. 0.51. What is the ratio of the Cost (as % of GNI) of Water in 1998 to that in 1999?
Keep it short and to the point. 0.94. What is the ratio of the Cost (as % of GNI) of Coal in 1998 to that in 2000?
Provide a succinct answer. 4.65. What is the ratio of the Cost (as % of GNI) in Minerals in 1998 to that in 2000?
Your answer should be compact. 4.11. What is the ratio of the Cost (as % of GNI) in Energy in 1998 to that in 2000?
Your response must be concise. 1.44. What is the ratio of the Cost (as % of GNI) of Water in 1998 to that in 2000?
Keep it short and to the point. 3.48. What is the ratio of the Cost (as % of GNI) in Coal in 1998 to that in 2001?
Give a very brief answer. 1.68. What is the ratio of the Cost (as % of GNI) of Minerals in 1998 to that in 2001?
Ensure brevity in your answer.  2.04. What is the ratio of the Cost (as % of GNI) in Energy in 1998 to that in 2001?
Your answer should be compact. 0.61. What is the ratio of the Cost (as % of GNI) in Water in 1998 to that in 2001?
Provide a short and direct response. 1.27. What is the ratio of the Cost (as % of GNI) in Coal in 1998 to that in 2002?
Your answer should be compact. 1.82. What is the ratio of the Cost (as % of GNI) of Minerals in 1998 to that in 2002?
Ensure brevity in your answer.  1.78. What is the ratio of the Cost (as % of GNI) in Energy in 1998 to that in 2002?
Offer a terse response. 0.77. What is the ratio of the Cost (as % of GNI) in Water in 1998 to that in 2002?
Offer a terse response. 1.19. What is the ratio of the Cost (as % of GNI) in Coal in 1999 to that in 2000?
Offer a terse response. 5.76. What is the ratio of the Cost (as % of GNI) in Minerals in 1999 to that in 2000?
Provide a short and direct response. 4.63. What is the ratio of the Cost (as % of GNI) of Energy in 1999 to that in 2000?
Give a very brief answer. 2.84. What is the ratio of the Cost (as % of GNI) in Water in 1999 to that in 2000?
Your answer should be compact. 3.7. What is the ratio of the Cost (as % of GNI) of Coal in 1999 to that in 2001?
Your answer should be very brief. 2.08. What is the ratio of the Cost (as % of GNI) of Minerals in 1999 to that in 2001?
Give a very brief answer. 2.3. What is the ratio of the Cost (as % of GNI) of Energy in 1999 to that in 2001?
Offer a very short reply. 1.21. What is the ratio of the Cost (as % of GNI) in Water in 1999 to that in 2001?
Your response must be concise. 1.35. What is the ratio of the Cost (as % of GNI) of Coal in 1999 to that in 2002?
Offer a very short reply. 2.26. What is the ratio of the Cost (as % of GNI) in Minerals in 1999 to that in 2002?
Make the answer very short. 2.01. What is the ratio of the Cost (as % of GNI) in Energy in 1999 to that in 2002?
Your response must be concise. 1.53. What is the ratio of the Cost (as % of GNI) of Water in 1999 to that in 2002?
Provide a short and direct response. 1.27. What is the ratio of the Cost (as % of GNI) in Coal in 2000 to that in 2001?
Your answer should be very brief. 0.36. What is the ratio of the Cost (as % of GNI) of Minerals in 2000 to that in 2001?
Keep it short and to the point. 0.5. What is the ratio of the Cost (as % of GNI) in Energy in 2000 to that in 2001?
Provide a short and direct response. 0.42. What is the ratio of the Cost (as % of GNI) in Water in 2000 to that in 2001?
Make the answer very short. 0.36. What is the ratio of the Cost (as % of GNI) in Coal in 2000 to that in 2002?
Provide a succinct answer. 0.39. What is the ratio of the Cost (as % of GNI) in Minerals in 2000 to that in 2002?
Offer a terse response. 0.43. What is the ratio of the Cost (as % of GNI) of Energy in 2000 to that in 2002?
Provide a succinct answer. 0.54. What is the ratio of the Cost (as % of GNI) of Water in 2000 to that in 2002?
Keep it short and to the point. 0.34. What is the ratio of the Cost (as % of GNI) in Coal in 2001 to that in 2002?
Provide a short and direct response. 1.09. What is the ratio of the Cost (as % of GNI) of Minerals in 2001 to that in 2002?
Keep it short and to the point. 0.87. What is the ratio of the Cost (as % of GNI) of Energy in 2001 to that in 2002?
Offer a very short reply. 1.27. What is the ratio of the Cost (as % of GNI) in Water in 2001 to that in 2002?
Give a very brief answer. 0.94. What is the difference between the highest and the second highest Cost (as % of GNI) of Coal?
Keep it short and to the point. 0.02. What is the difference between the highest and the second highest Cost (as % of GNI) of Minerals?
Your answer should be very brief. 0.12. What is the difference between the highest and the second highest Cost (as % of GNI) of Energy?
Ensure brevity in your answer.  0.34. What is the difference between the highest and the second highest Cost (as % of GNI) in Water?
Ensure brevity in your answer.  0.89. What is the difference between the highest and the lowest Cost (as % of GNI) in Coal?
Your answer should be compact. 0.31. What is the difference between the highest and the lowest Cost (as % of GNI) in Minerals?
Make the answer very short. 0.46. What is the difference between the highest and the lowest Cost (as % of GNI) of Energy?
Ensure brevity in your answer.  1.73. What is the difference between the highest and the lowest Cost (as % of GNI) of Water?
Ensure brevity in your answer.  10.74. 